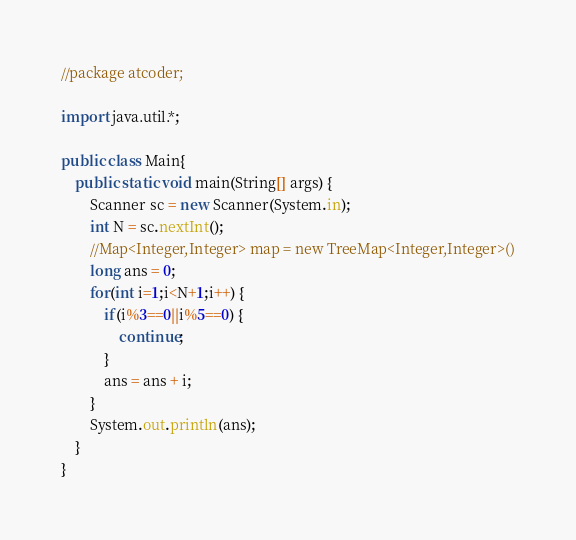<code> <loc_0><loc_0><loc_500><loc_500><_Java_>//package atcoder;
 
import java.util.*;
 
public class Main{
	public static void main(String[] args) {
		Scanner sc = new Scanner(System.in);
		int N = sc.nextInt();
		//Map<Integer,Integer> map = new TreeMap<Integer,Integer>()
		long ans = 0;
		for(int i=1;i<N+1;i++) {
			if(i%3==0||i%5==0) {
				continue;
			}
			ans = ans + i;
		}
		System.out.println(ans);
	}
}</code> 